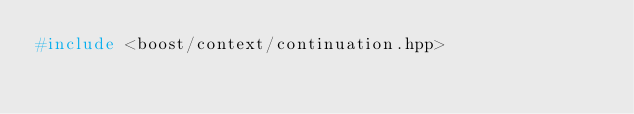<code> <loc_0><loc_0><loc_500><loc_500><_C++_>#include <boost/context/continuation.hpp>
</code> 